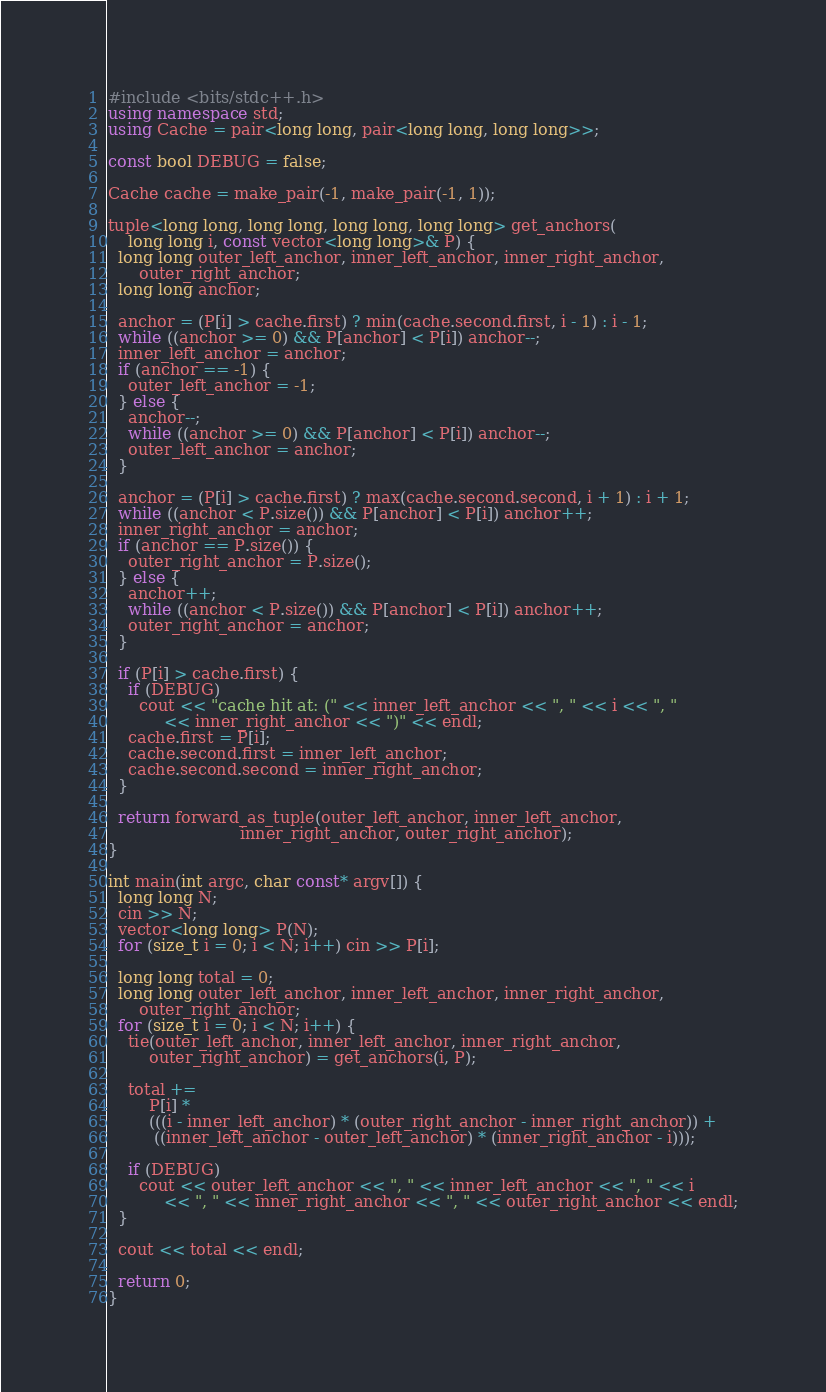<code> <loc_0><loc_0><loc_500><loc_500><_C++_>#include <bits/stdc++.h>
using namespace std;
using Cache = pair<long long, pair<long long, long long>>;

const bool DEBUG = false;

Cache cache = make_pair(-1, make_pair(-1, 1));

tuple<long long, long long, long long, long long> get_anchors(
    long long i, const vector<long long>& P) {
  long long outer_left_anchor, inner_left_anchor, inner_right_anchor,
      outer_right_anchor;
  long long anchor;

  anchor = (P[i] > cache.first) ? min(cache.second.first, i - 1) : i - 1;
  while ((anchor >= 0) && P[anchor] < P[i]) anchor--;
  inner_left_anchor = anchor;
  if (anchor == -1) {
    outer_left_anchor = -1;
  } else {
    anchor--;
    while ((anchor >= 0) && P[anchor] < P[i]) anchor--;
    outer_left_anchor = anchor;
  }

  anchor = (P[i] > cache.first) ? max(cache.second.second, i + 1) : i + 1;
  while ((anchor < P.size()) && P[anchor] < P[i]) anchor++;
  inner_right_anchor = anchor;
  if (anchor == P.size()) {
    outer_right_anchor = P.size();
  } else {
    anchor++;
    while ((anchor < P.size()) && P[anchor] < P[i]) anchor++;
    outer_right_anchor = anchor;
  }

  if (P[i] > cache.first) {
    if (DEBUG)
      cout << "cache hit at: (" << inner_left_anchor << ", " << i << ", "
           << inner_right_anchor << ")" << endl;
    cache.first = P[i];
    cache.second.first = inner_left_anchor;
    cache.second.second = inner_right_anchor;
  }

  return forward_as_tuple(outer_left_anchor, inner_left_anchor,
                          inner_right_anchor, outer_right_anchor);
}

int main(int argc, char const* argv[]) {
  long long N;
  cin >> N;
  vector<long long> P(N);
  for (size_t i = 0; i < N; i++) cin >> P[i];

  long long total = 0;
  long long outer_left_anchor, inner_left_anchor, inner_right_anchor,
      outer_right_anchor;
  for (size_t i = 0; i < N; i++) {
    tie(outer_left_anchor, inner_left_anchor, inner_right_anchor,
        outer_right_anchor) = get_anchors(i, P);

    total +=
        P[i] *
        (((i - inner_left_anchor) * (outer_right_anchor - inner_right_anchor)) +
         ((inner_left_anchor - outer_left_anchor) * (inner_right_anchor - i)));

    if (DEBUG)
      cout << outer_left_anchor << ", " << inner_left_anchor << ", " << i
           << ", " << inner_right_anchor << ", " << outer_right_anchor << endl;
  }

  cout << total << endl;

  return 0;
}
</code> 